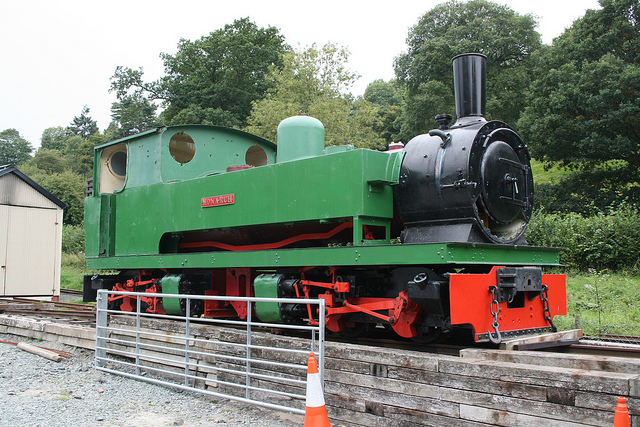<image>What is the name on the side of the train pictured? I am not sure what is the name on the side of the train. It can be 'csx', 'monarch', 'monroe' but It might not also be readable. What is the name on the side of the train pictured? I don't know the name on the side of the train pictured. It is either 'csx', 'monarch', 'train', 'monorail', 'monroe' or I can't read it. 